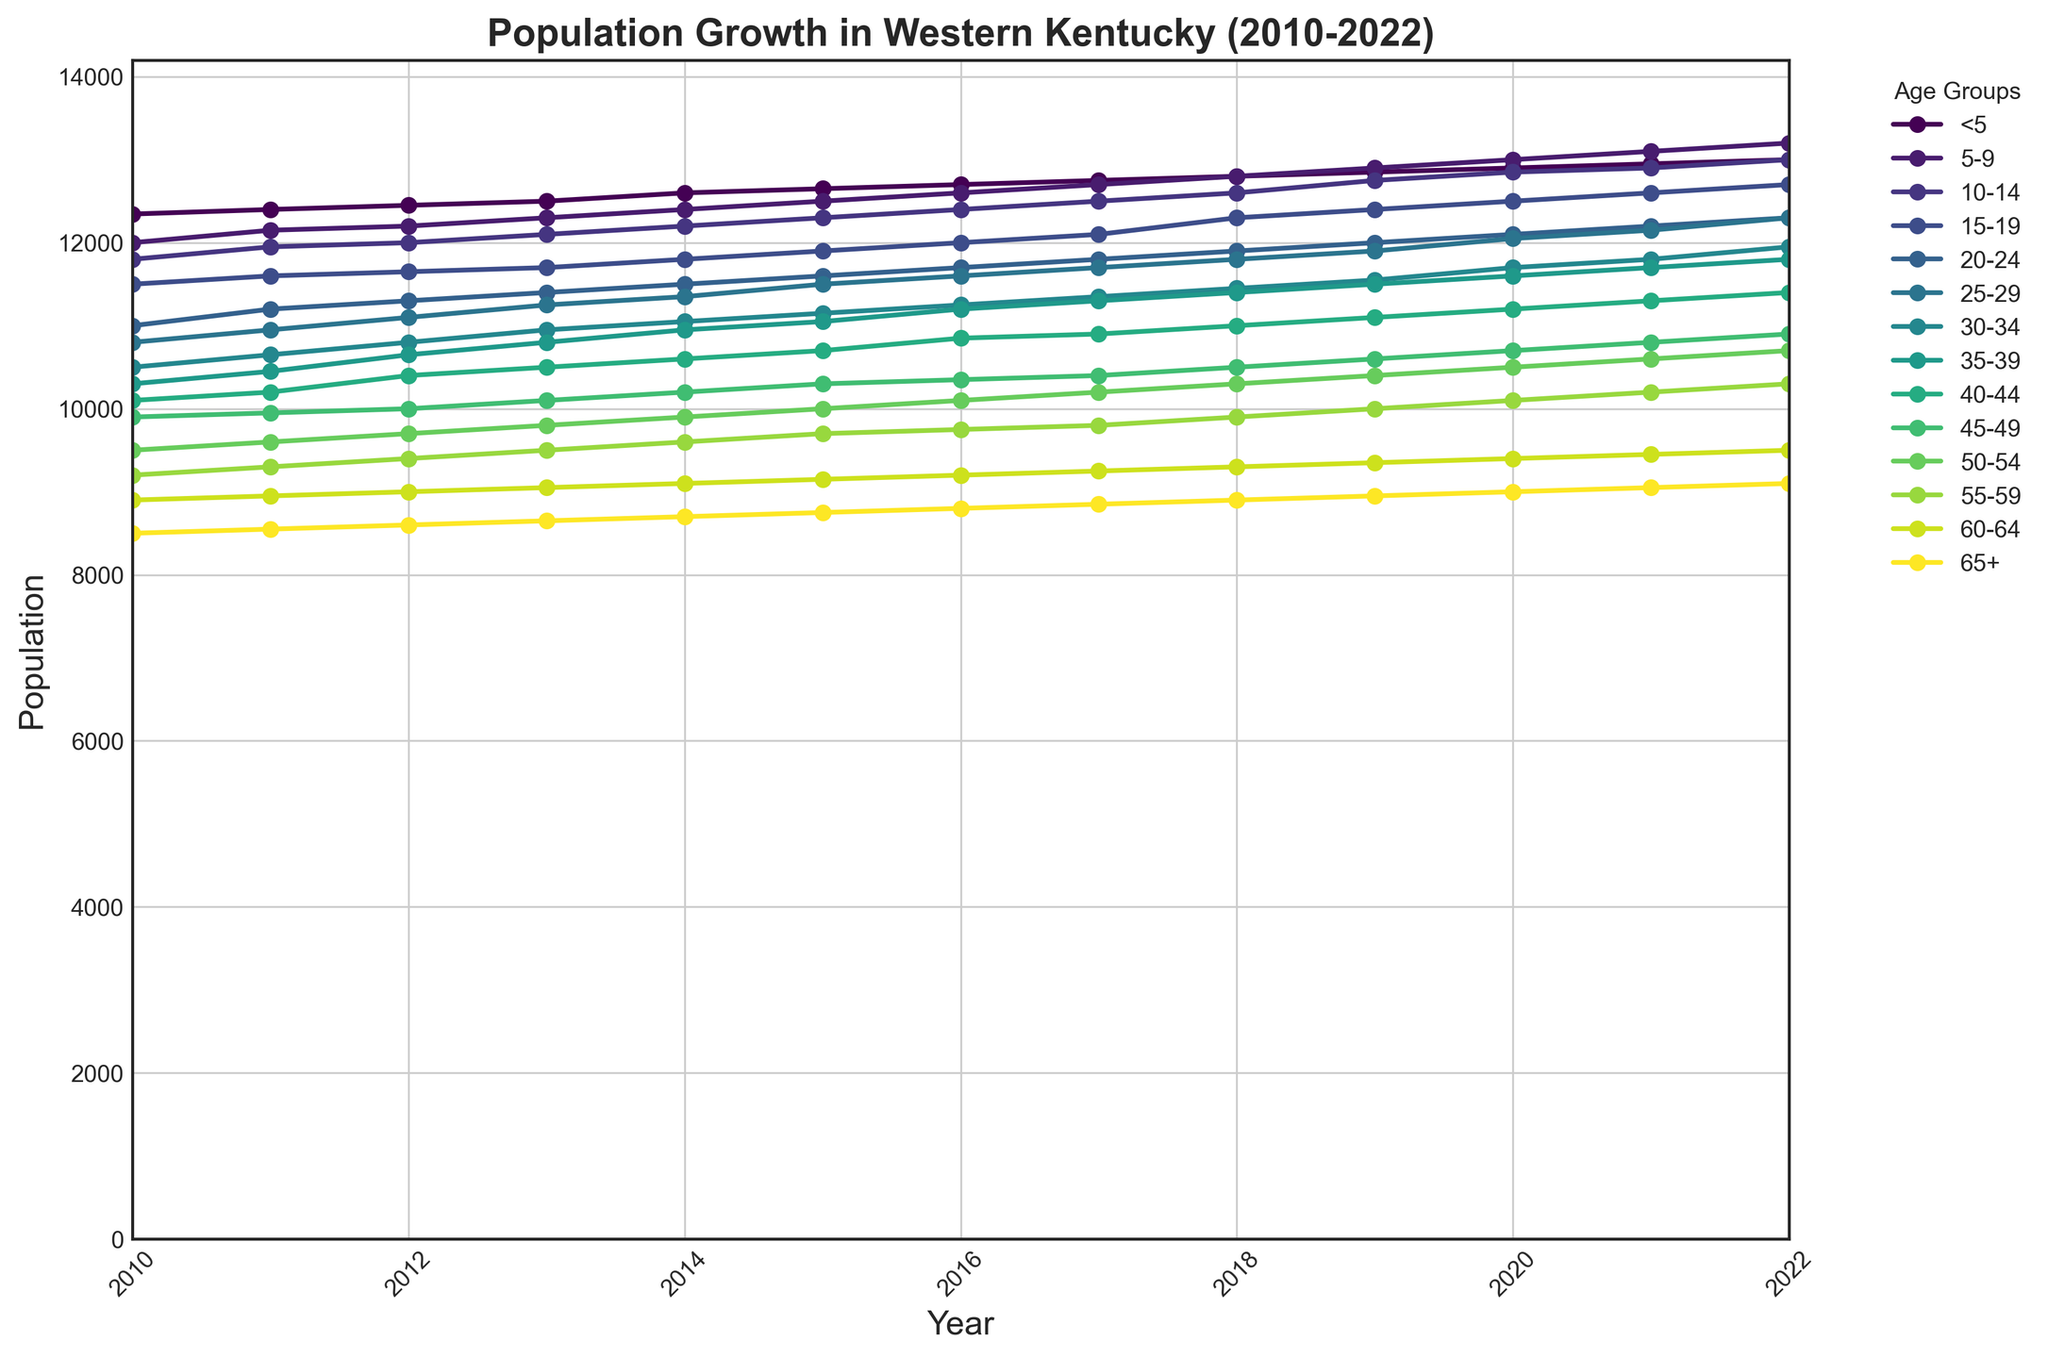What is the age group with the highest population in 2022? By observing the line chart, the age group with the highest endpoint in 2022 indicates the highest population. The age group "5-9" has the highest end value.
Answer: 5-9 Which age group experienced the most significant overall growth between 2010 and 2022? To determine this, find the difference between the population values for each age group in 2010 and 2022. The age group "5-9" shows the largest increment.
Answer: 5-9 Did the population of the "20-24" age group ever decline between consecutive years, and if so, which years? Look at the line for the "20-24" age group and check for any years where the line slopes downward. In 2012, the population of the "20-24" age group decreased compared to 2011.
Answer: 2012 How did the population of the "60-64" age group change from 2010 to 2022? Check the values of the "60-64" age group in 2010 and 2022 directly from the chart. The population increased from 8900 in 2010 to 9500 in 2022.
Answer: Increased by 600 Compare the population trends of "30-34" and "65+" age groups. Which age group had a more steady increase over the years? To compare, observe the slopes of the lines for "30-34" and "65+" age groups. The "65+" age group shows a steadier, more gradual increase compared to "30-34," which shows some variability.
Answer: 65+ Which two age groups had the closest population values in 2015? Find 2015 on the x-axis and look at the y-values for all age groups. The "25-29" and "30-34" age groups are closest in population in 2015.
Answer: 25-29 and 30-34 In what year did the population of the "55-59" age group surpass 10,000 for the first time? Trace the "55-59" line and find the first year where it crosses the 10,000 mark on the y-axis. This occurred in the year 2021.
Answer: 2021 What is the average population of the "40-44" age group from 2010 to 2022? Sum the populations of the "40-44" age group from all years and divide by the number of years (13). The sum is 142450, so the average is 142450 / 13 ≈ 10958.
Answer: 10958 By how much did the population of the "25-29" age group increase from 2015 to 2022? Subtract the population of the "25-29" age group in 2015 from its population in 2022. The increase is 12300 - 11500 = 800.
Answer: 800 